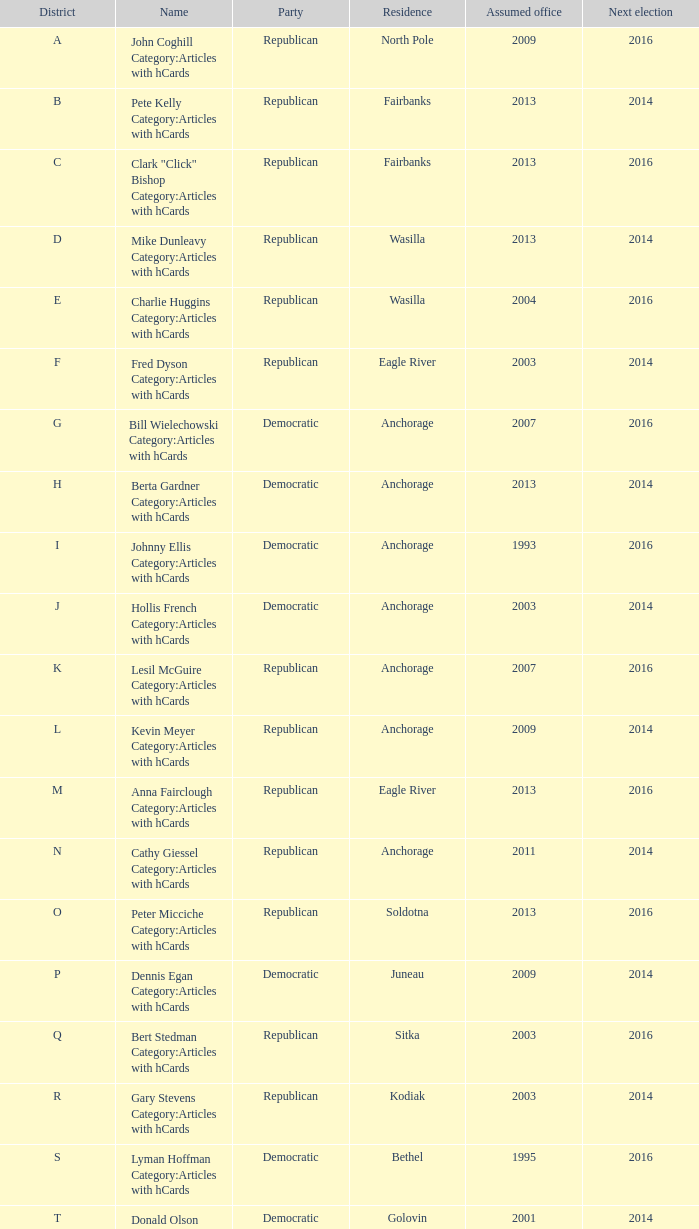Can you parse all the data within this table? {'header': ['District', 'Name', 'Party', 'Residence', 'Assumed office', 'Next election'], 'rows': [['A', 'John Coghill Category:Articles with hCards', 'Republican', 'North Pole', '2009', '2016'], ['B', 'Pete Kelly Category:Articles with hCards', 'Republican', 'Fairbanks', '2013', '2014'], ['C', 'Clark "Click" Bishop Category:Articles with hCards', 'Republican', 'Fairbanks', '2013', '2016'], ['D', 'Mike Dunleavy Category:Articles with hCards', 'Republican', 'Wasilla', '2013', '2014'], ['E', 'Charlie Huggins Category:Articles with hCards', 'Republican', 'Wasilla', '2004', '2016'], ['F', 'Fred Dyson Category:Articles with hCards', 'Republican', 'Eagle River', '2003', '2014'], ['G', 'Bill Wielechowski Category:Articles with hCards', 'Democratic', 'Anchorage', '2007', '2016'], ['H', 'Berta Gardner Category:Articles with hCards', 'Democratic', 'Anchorage', '2013', '2014'], ['I', 'Johnny Ellis Category:Articles with hCards', 'Democratic', 'Anchorage', '1993', '2016'], ['J', 'Hollis French Category:Articles with hCards', 'Democratic', 'Anchorage', '2003', '2014'], ['K', 'Lesil McGuire Category:Articles with hCards', 'Republican', 'Anchorage', '2007', '2016'], ['L', 'Kevin Meyer Category:Articles with hCards', 'Republican', 'Anchorage', '2009', '2014'], ['M', 'Anna Fairclough Category:Articles with hCards', 'Republican', 'Eagle River', '2013', '2016'], ['N', 'Cathy Giessel Category:Articles with hCards', 'Republican', 'Anchorage', '2011', '2014'], ['O', 'Peter Micciche Category:Articles with hCards', 'Republican', 'Soldotna', '2013', '2016'], ['P', 'Dennis Egan Category:Articles with hCards', 'Democratic', 'Juneau', '2009', '2014'], ['Q', 'Bert Stedman Category:Articles with hCards', 'Republican', 'Sitka', '2003', '2016'], ['R', 'Gary Stevens Category:Articles with hCards', 'Republican', 'Kodiak', '2003', '2014'], ['S', 'Lyman Hoffman Category:Articles with hCards', 'Democratic', 'Bethel', '1995', '2016'], ['T', 'Donald Olson Category:Articles with hCards', 'Democratic', 'Golovin', '2001', '2014']]} What is the party of the Senator in District A, who assumed office before 2013 and will be up for re-election after 2014? Republican. 